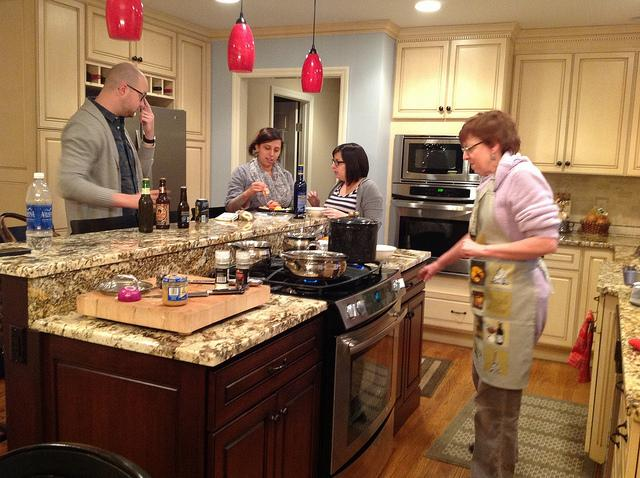What type of energy is being used by the stove? Please explain your reasoning. gas. Gas is being used. 